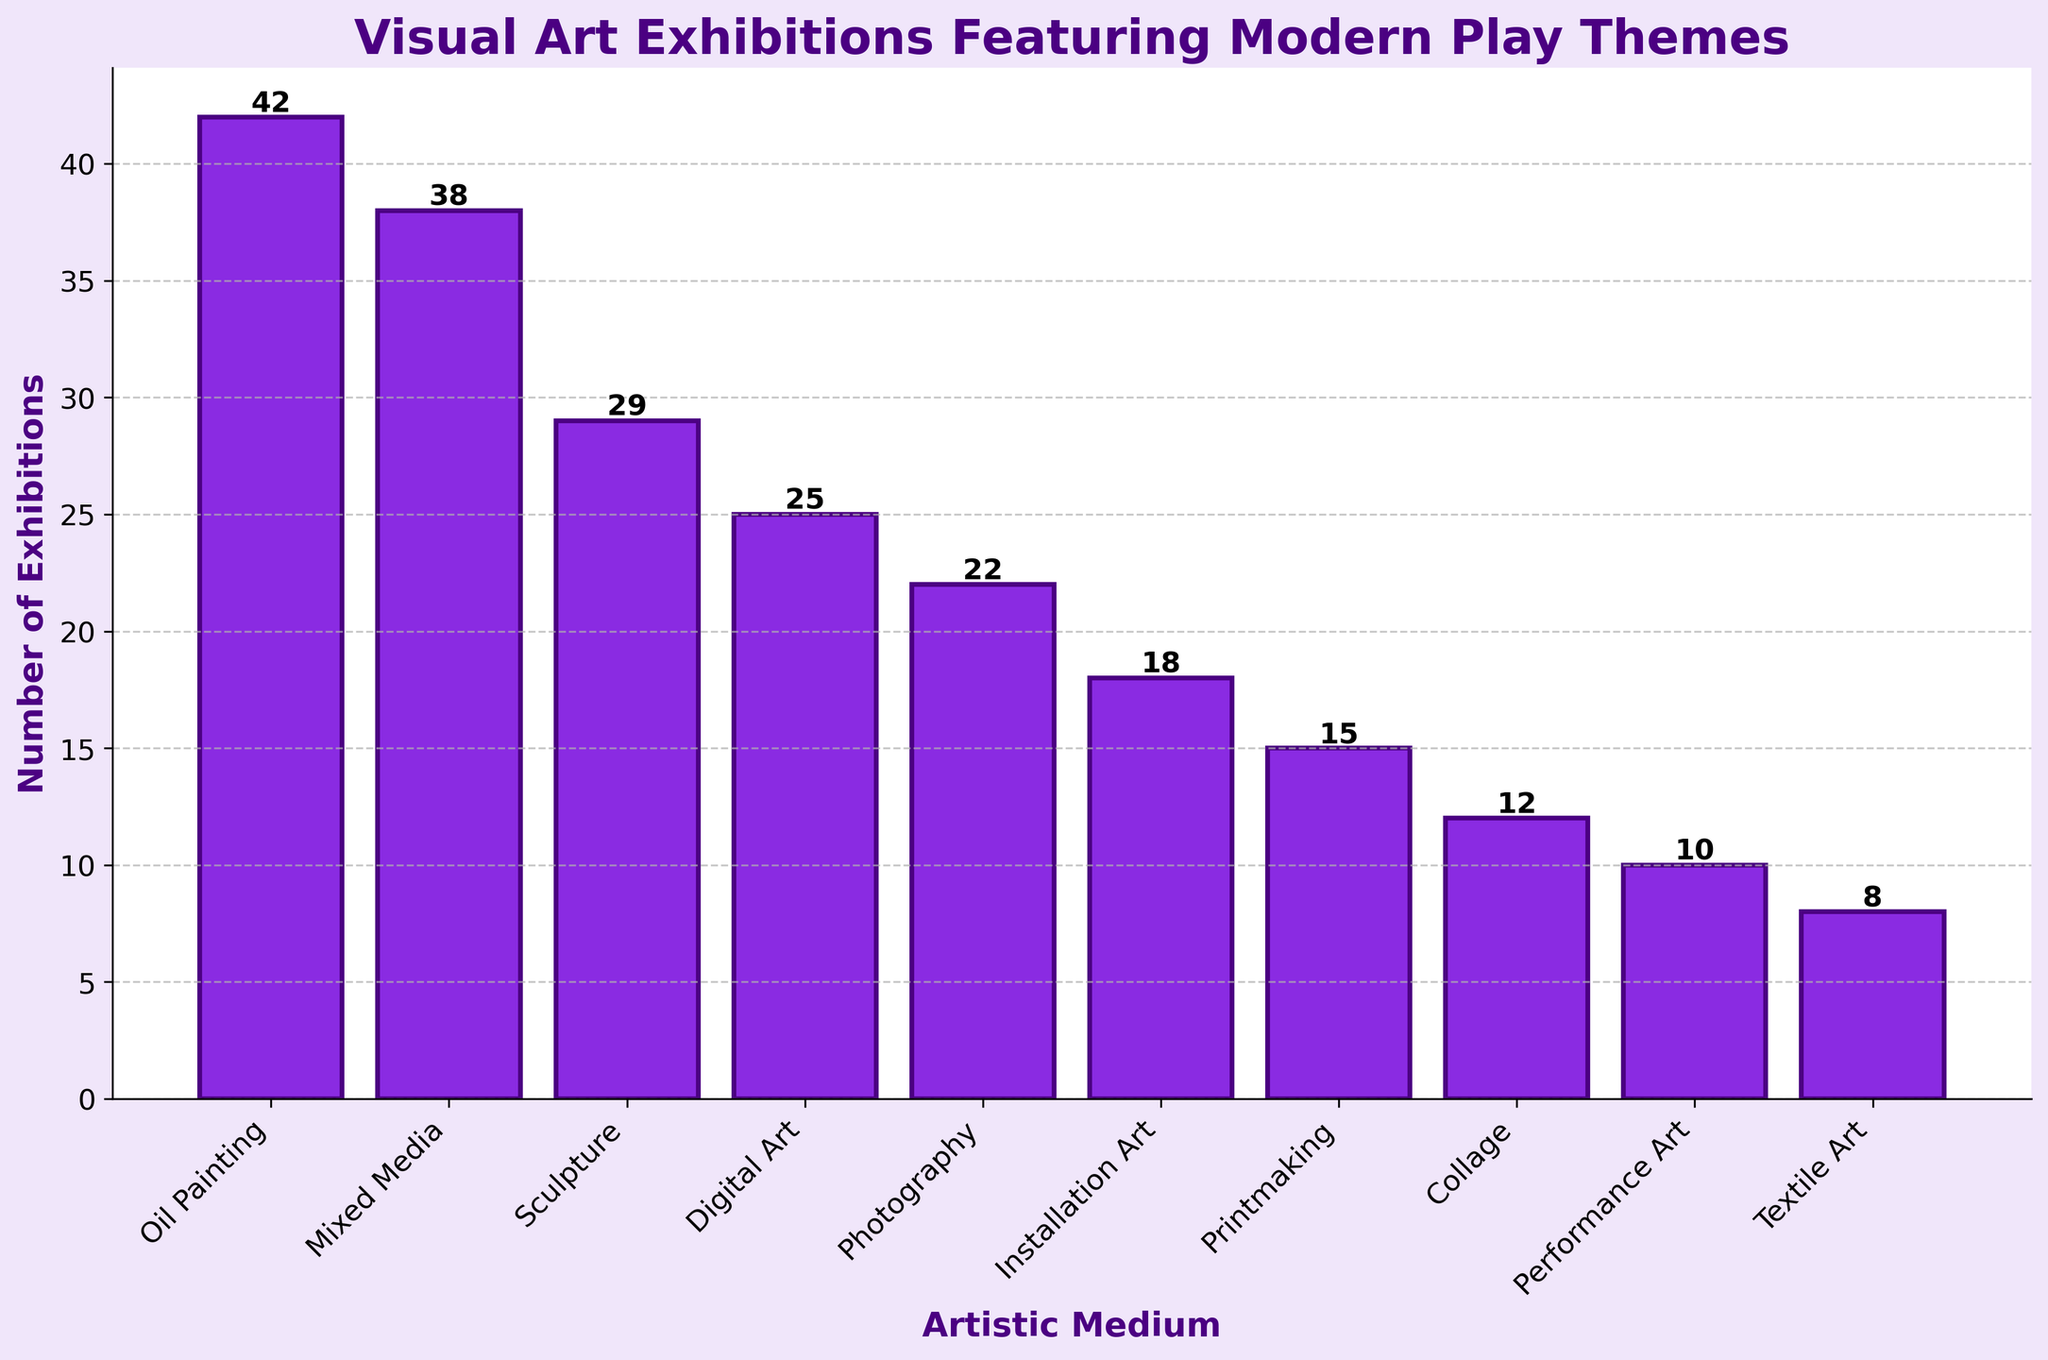Which artistic medium has the most exhibitions? The bar for "Oil Painting" is the tallest when visually comparing the height of all bars in the figure, indicating that "Oil Painting" has the highest number of exhibitions.
Answer: Oil Painting What is the total number of exhibitions for Sculpture, Digital Art, and Photography combined? The number of exhibitions for Sculpture, Digital Art, and Photography are 29, 25, and 22 respectively. Adding these together gives 29 + 25 + 22 = 76.
Answer: 76 How many more exhibitions does Mixed Media have compared to Textile Art? Mixed Media has 38 exhibitions while Textile Art has 8. The difference is 38 - 8 = 30.
Answer: 30 Which medium has fewer exhibitions: Installation Art or Printmaking? Comparing the bars for Installation Art and Printmaking, the bar for Installation Art is shorter. Installation Art has 18 exhibitions, while Printmaking has 15. Therefore, Printmaking has fewer exhibitions.
Answer: Printmaking What is the average number of exhibitions for Performance Art, Collage, and Textile Art? The number of exhibitions for Performance Art, Collage, and Textile Art are 10, 12, and 8 respectively. The average is calculated as (10 + 12 + 8) / 3 = 30 / 3 = 10.
Answer: 10 What is the smallest number of exhibitions shown on the chart? The shortest bar on the plot represents Textile Art, which has 8 exhibitions.
Answer: 8 Are there more exhibitions for Digital Art than for Installation Art and Printmaking combined? The number of exhibitions for Digital Art is 25. The combined number of exhibitions for Installation Art and Printmaking is 18 + 15 = 33. Since 25 is less than 33, there are not more exhibitions for Digital Art than for the combined total of Installation Art and Printmaking.
Answer: No By how many exhibitions does Oil Painting exceed Performance Art? Oil Painting has 42 exhibitions while Performance Art has 10. The excess amount is 42 - 10 = 32.
Answer: 32 What is the difference between the number of exhibitions for Mixed Media and Digital Art? Mixed Media has 38 exhibitions and Digital Art has 25. The difference is 38 - 25 = 13.
Answer: 13 